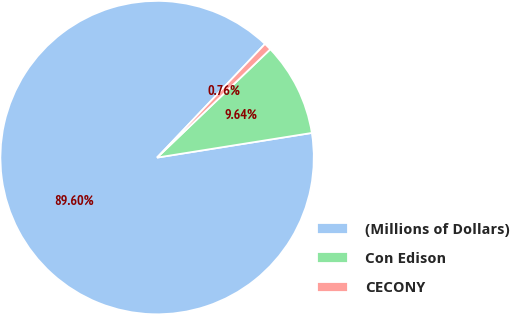<chart> <loc_0><loc_0><loc_500><loc_500><pie_chart><fcel>(Millions of Dollars)<fcel>Con Edison<fcel>CECONY<nl><fcel>89.6%<fcel>9.64%<fcel>0.76%<nl></chart> 